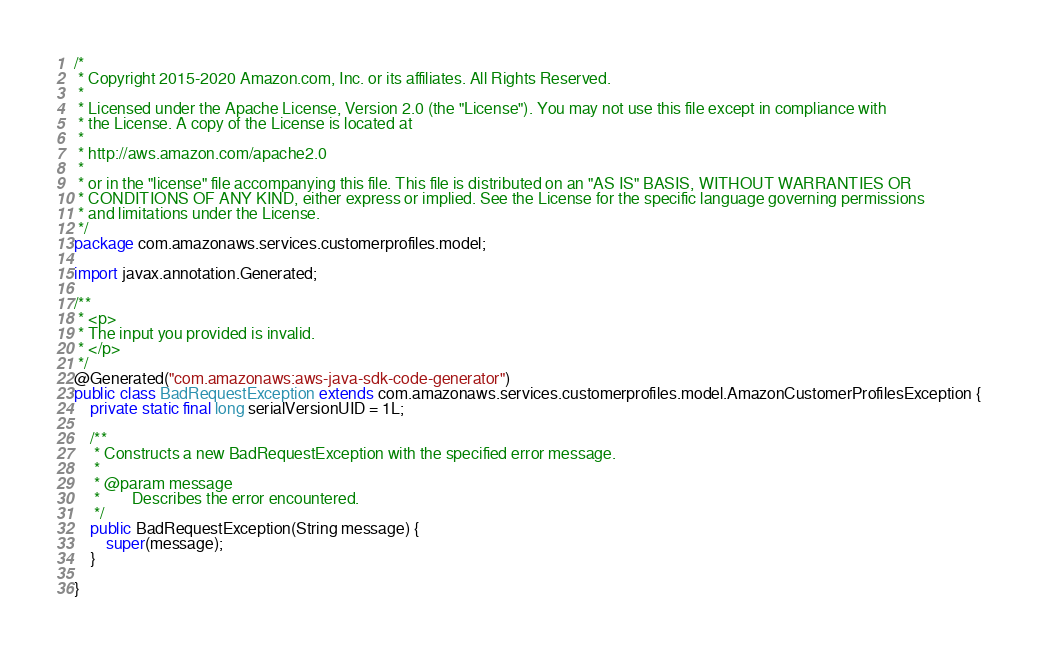<code> <loc_0><loc_0><loc_500><loc_500><_Java_>/*
 * Copyright 2015-2020 Amazon.com, Inc. or its affiliates. All Rights Reserved.
 * 
 * Licensed under the Apache License, Version 2.0 (the "License"). You may not use this file except in compliance with
 * the License. A copy of the License is located at
 * 
 * http://aws.amazon.com/apache2.0
 * 
 * or in the "license" file accompanying this file. This file is distributed on an "AS IS" BASIS, WITHOUT WARRANTIES OR
 * CONDITIONS OF ANY KIND, either express or implied. See the License for the specific language governing permissions
 * and limitations under the License.
 */
package com.amazonaws.services.customerprofiles.model;

import javax.annotation.Generated;

/**
 * <p>
 * The input you provided is invalid.
 * </p>
 */
@Generated("com.amazonaws:aws-java-sdk-code-generator")
public class BadRequestException extends com.amazonaws.services.customerprofiles.model.AmazonCustomerProfilesException {
    private static final long serialVersionUID = 1L;

    /**
     * Constructs a new BadRequestException with the specified error message.
     *
     * @param message
     *        Describes the error encountered.
     */
    public BadRequestException(String message) {
        super(message);
    }

}
</code> 